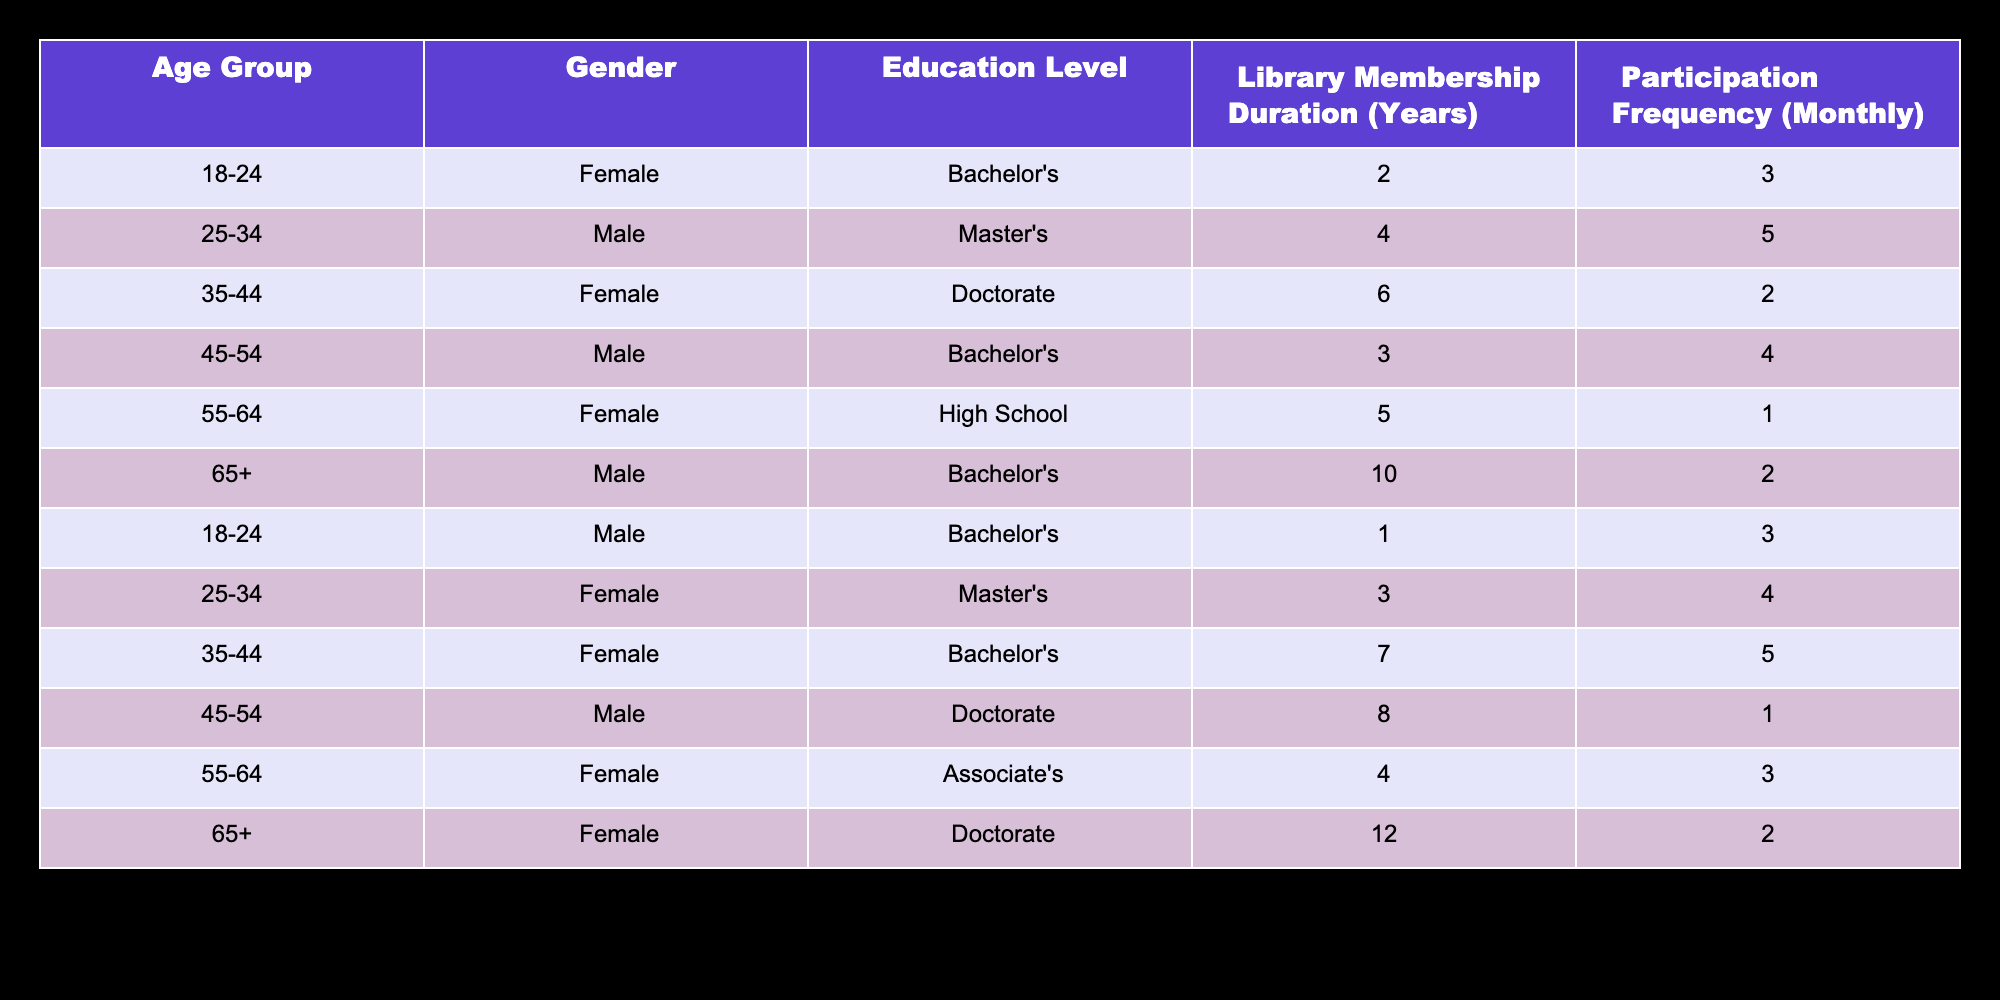What is the education level of the oldest patron group? The oldest patron group is classified as 65+, and looking at the table, I can see that this group includes two entries: one male with a Bachelor's degree and one female with a Doctorate. Therefore, the education levels represented are Bachelor's and Doctorate.
Answer: Bachelor's and Doctorate How many female patrons have a Master's degree? By inspecting the table, I find two entries that match these criteria: one female in the 25-34 age group and another in the 35-44 age group. Therefore, the total count of female patrons with a Master's degree is 2.
Answer: 2 What is the average library membership duration for male patrons? To find the average, I sum the library membership duration for all male patrons: 4 + 3 + 10 + 1 = 18 years. Then, I divide by the total male patrons, which is 4. Thus, the average membership duration is 18/4 = 4.5 years.
Answer: 4.5 Do more patrons participate in programs monthly in the age group 25-34 compared to other age groups? In the 25-34 age group, there are two entries with participation frequencies of 5 and 4, totaling 9. The frequency for other age groups is: 18-24 (3), 35-44 (7), 45-54 (4), 55-64 (4), and 65+ (4). The highest frequency comes from the 35-44 age group with 7, thus the 25-34 group does not have more total monthly participation than others.
Answer: No Which gender has a higher participation frequency overall, and what is the frequency amount? To answer this, I need to compute the total participation frequency for both genders. For females: 3 + 4 + 2 + 1 + 3 + 2 = 15; for males: 5 + 4 + 1 + 2 + 3 = 15. Both genders have the same total participation frequency of 15.
Answer: Both genders have equal frequency, which is 15 Are there any patrons in the age group 55-64 with a Doctorate degree? By reviewing the table, I see that in the 55-64 age group, there is one patron with an Associate's degree and one with a High School education, but none with a Doctorate. Therefore, it can be concluded that there are no patrons in that age group holding a Doctorate degree.
Answer: No 